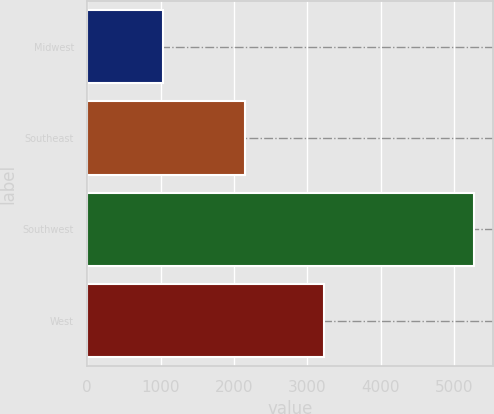Convert chart. <chart><loc_0><loc_0><loc_500><loc_500><bar_chart><fcel>Midwest<fcel>Southeast<fcel>Southwest<fcel>West<nl><fcel>1037<fcel>2148<fcel>5271<fcel>3228<nl></chart> 